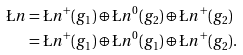Convert formula to latex. <formula><loc_0><loc_0><loc_500><loc_500>\L n & = \L n ^ { + } ( g _ { 1 } ) \oplus \L n ^ { 0 } ( g _ { 2 } ) \oplus \L n ^ { + } ( g _ { 2 } ) \\ & = \L n ^ { + } ( g _ { 1 } ) \oplus \L n ^ { 0 } ( g _ { 1 } ) \oplus \L n ^ { + } ( g _ { 2 } ) . \\</formula> 